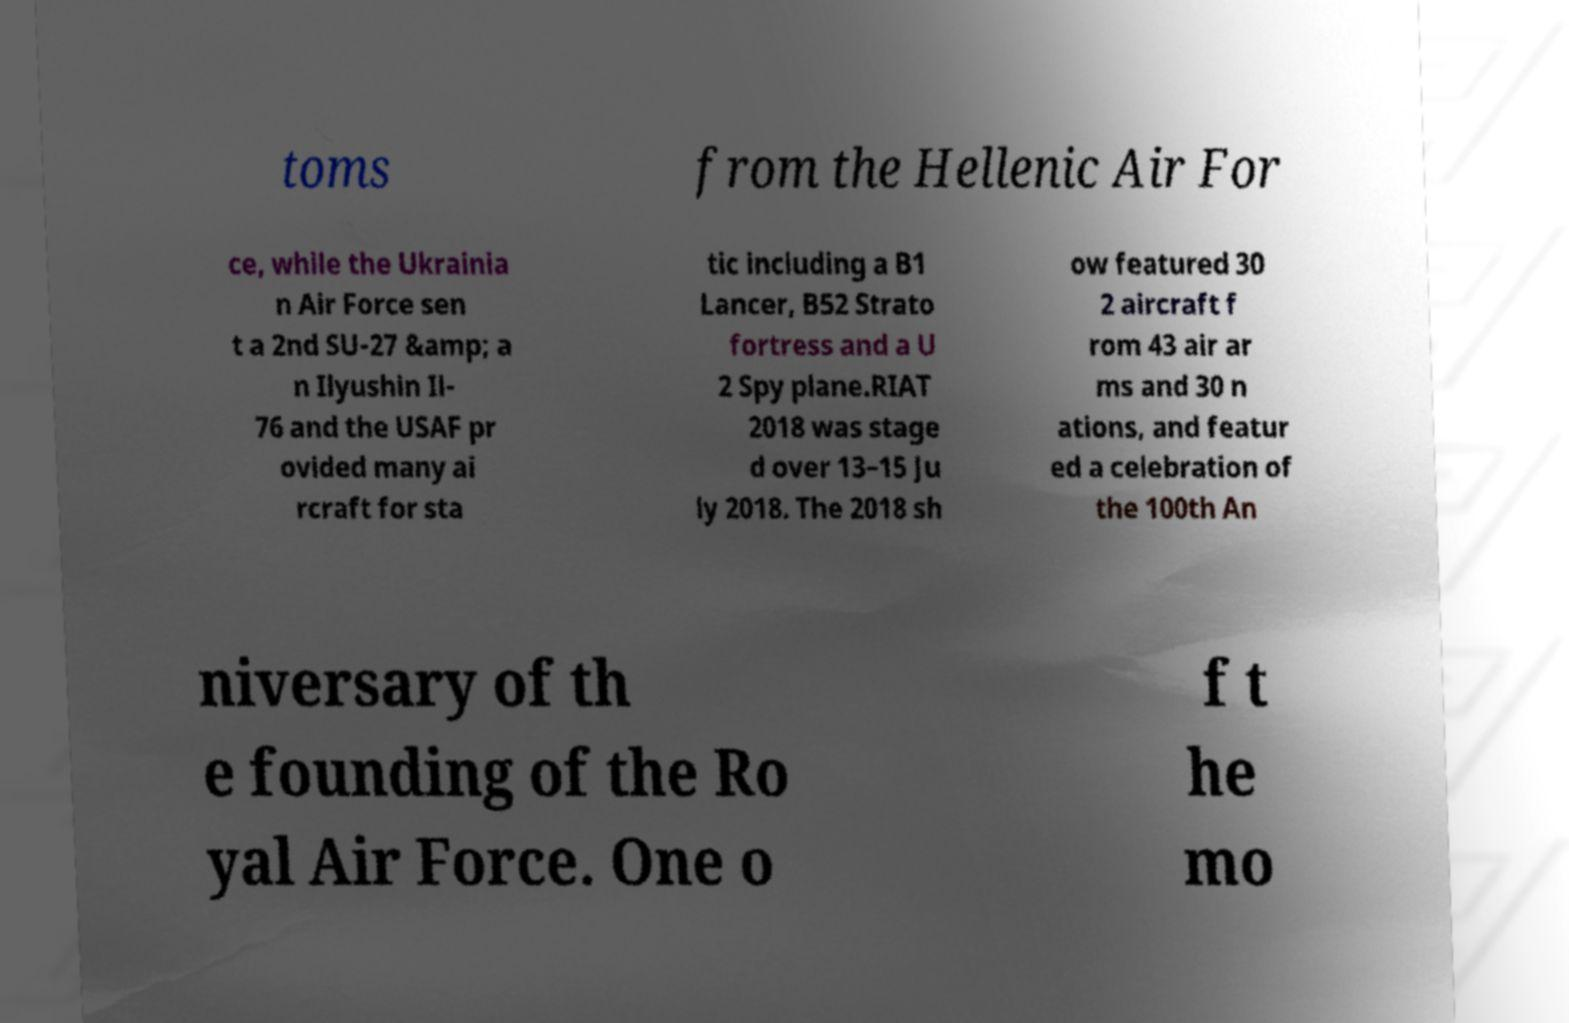For documentation purposes, I need the text within this image transcribed. Could you provide that? toms from the Hellenic Air For ce, while the Ukrainia n Air Force sen t a 2nd SU-27 &amp; a n Ilyushin Il- 76 and the USAF pr ovided many ai rcraft for sta tic including a B1 Lancer, B52 Strato fortress and a U 2 Spy plane.RIAT 2018 was stage d over 13–15 Ju ly 2018. The 2018 sh ow featured 30 2 aircraft f rom 43 air ar ms and 30 n ations, and featur ed a celebration of the 100th An niversary of th e founding of the Ro yal Air Force. One o f t he mo 